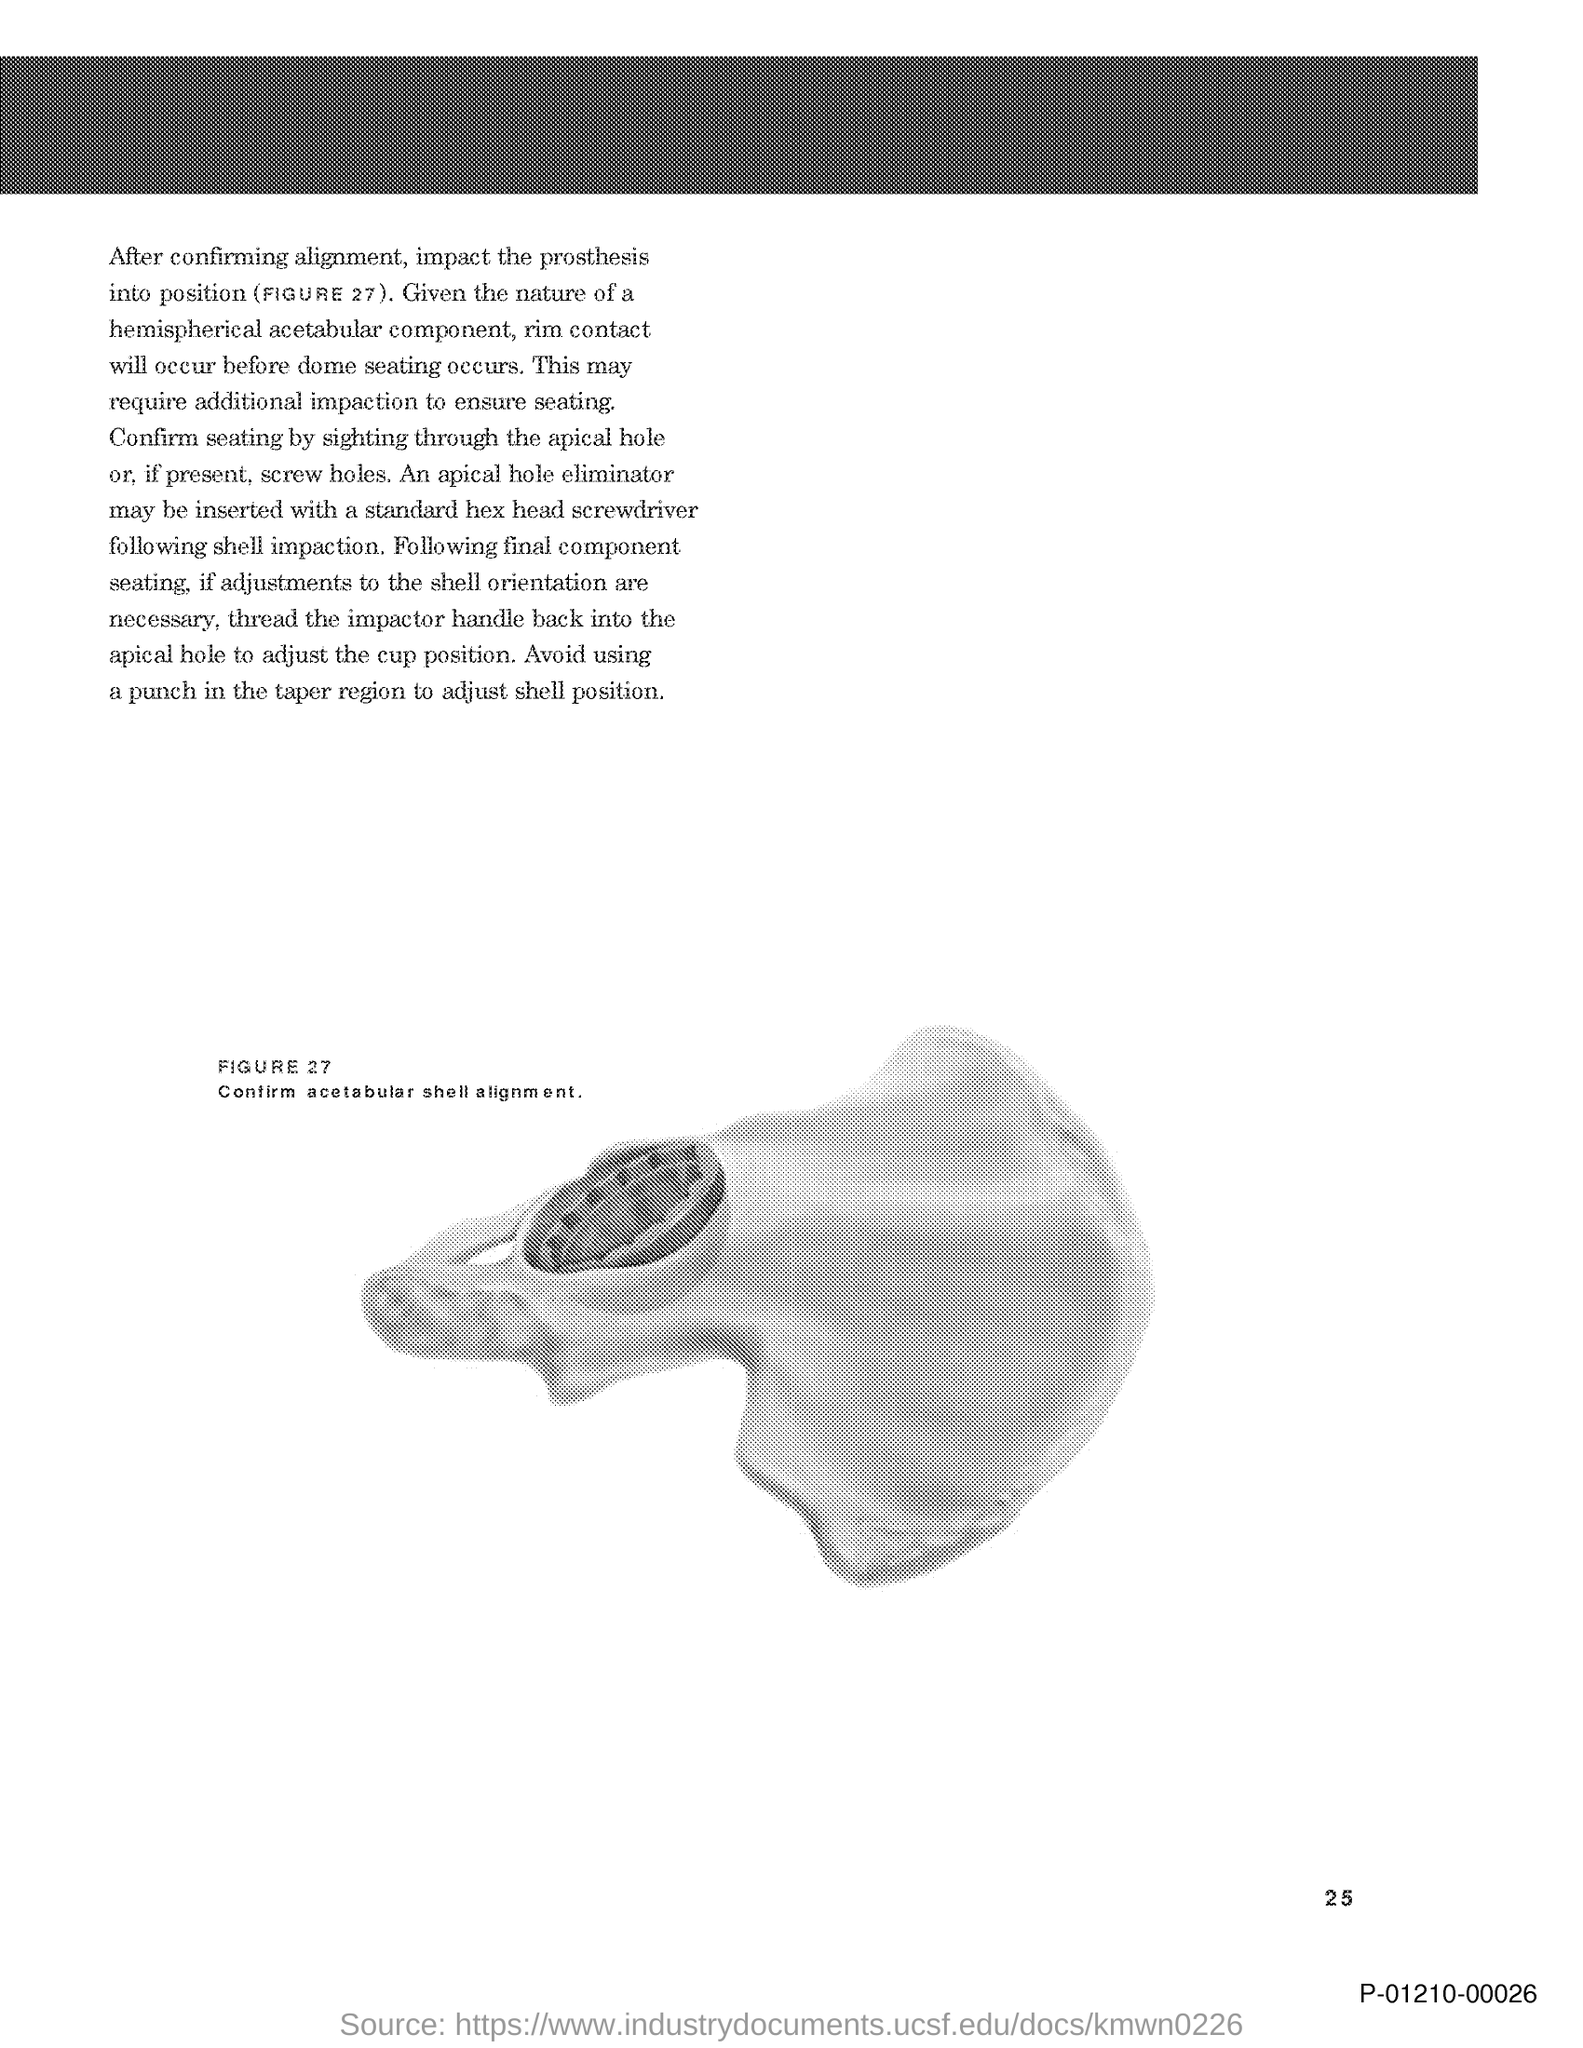What does Figure 27 represent?
Offer a very short reply. Confirm acetabular shell alignment. Why is it avoided to use a punch in the taper region?
Provide a short and direct response. To adjust shell position. 